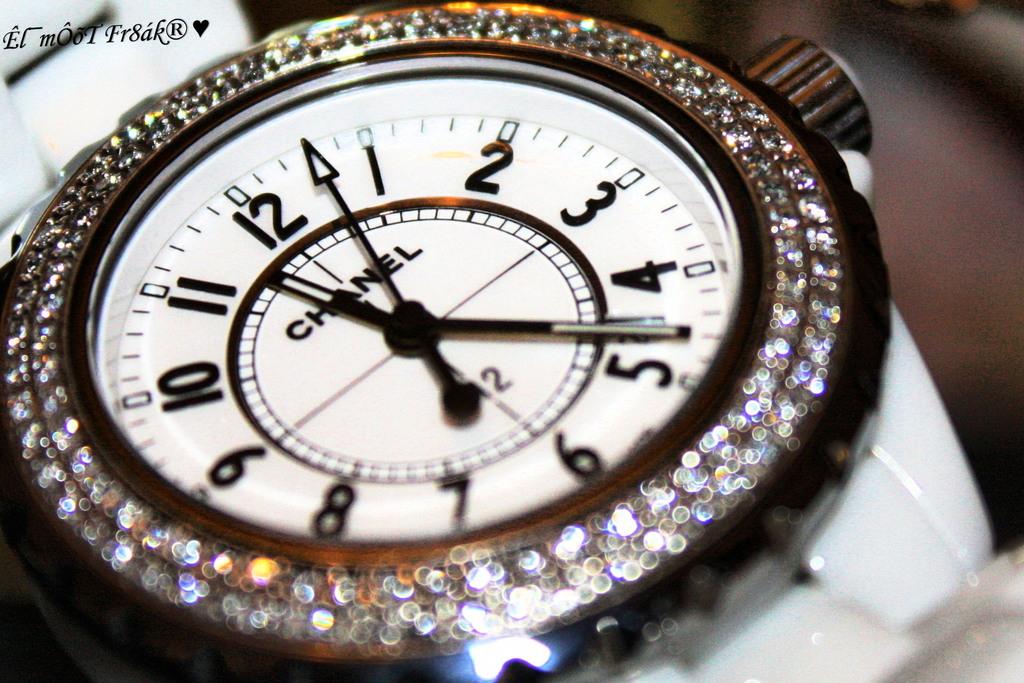Who made the watch?
Make the answer very short. Chanel. What time is shown on the watch?
Your answer should be very brief. 11:23. 